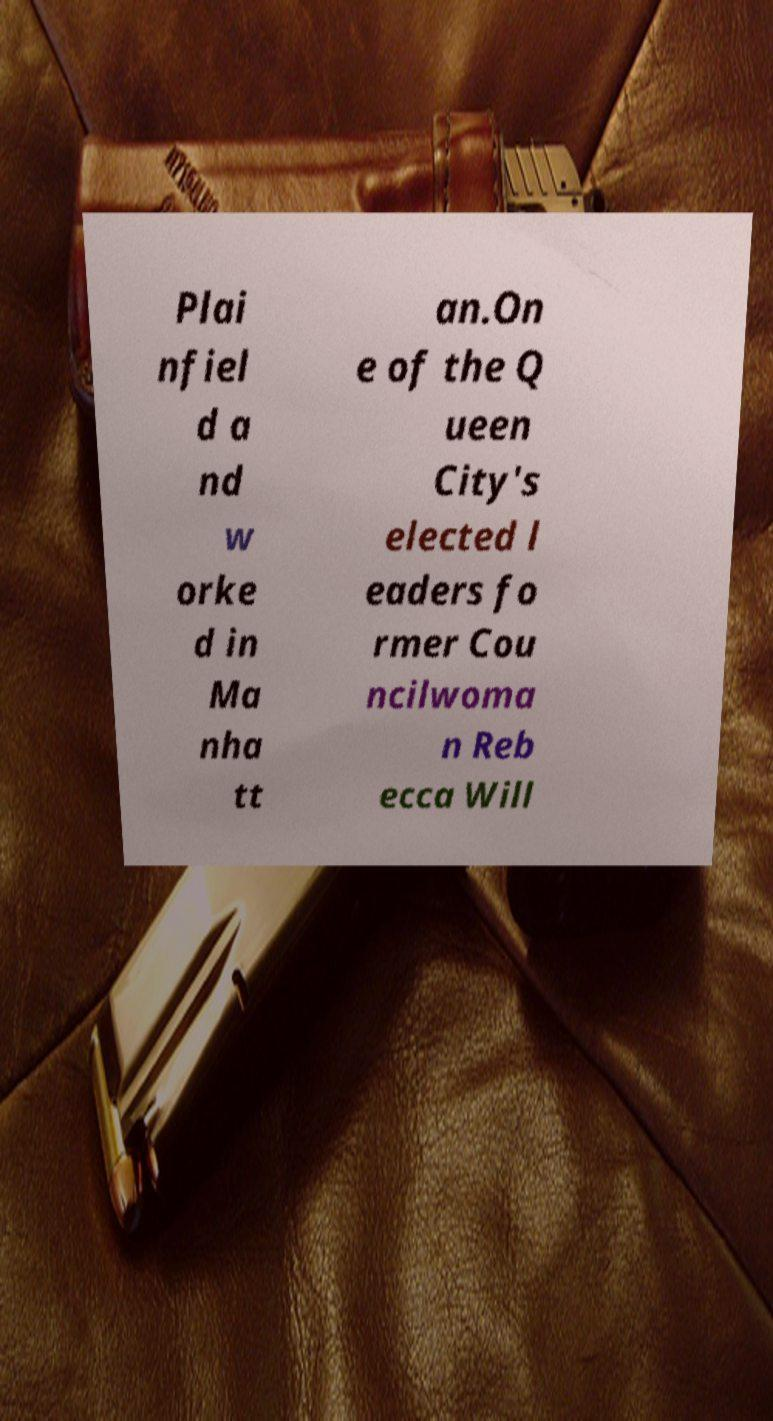I need the written content from this picture converted into text. Can you do that? Plai nfiel d a nd w orke d in Ma nha tt an.On e of the Q ueen City's elected l eaders fo rmer Cou ncilwoma n Reb ecca Will 